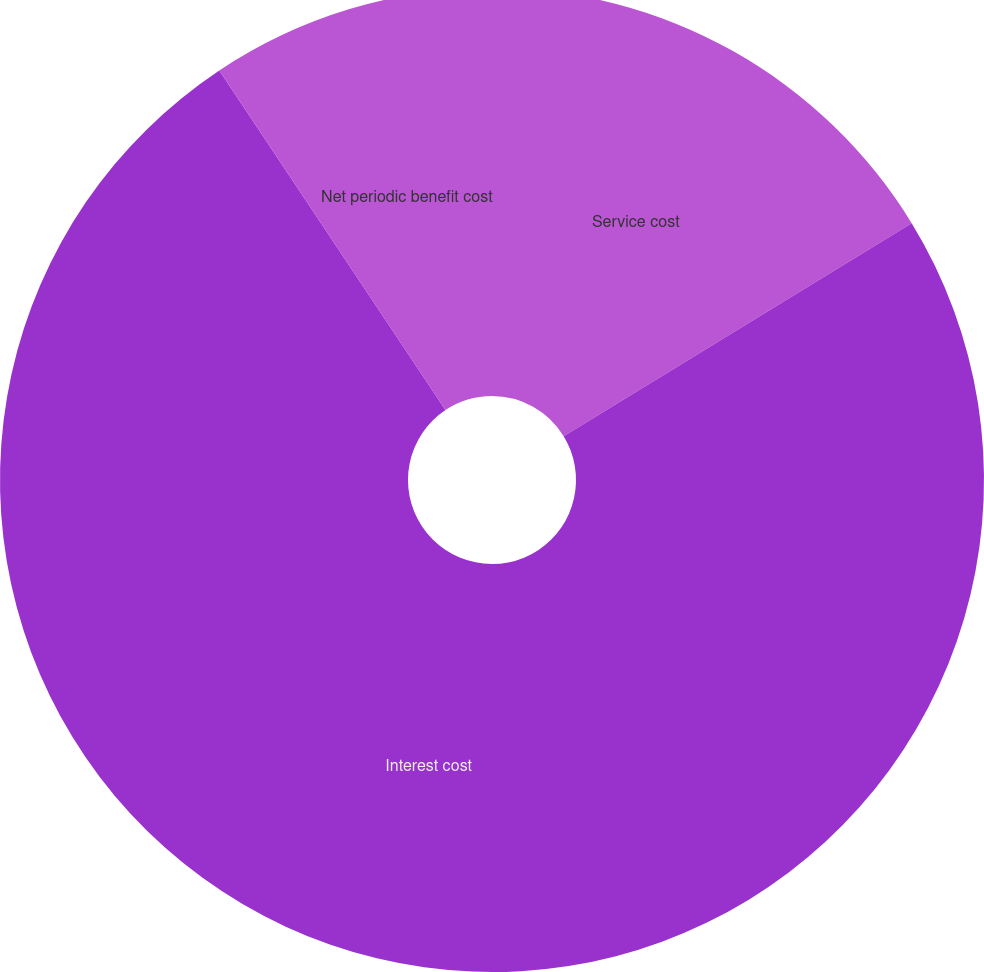Convert chart. <chart><loc_0><loc_0><loc_500><loc_500><pie_chart><fcel>Service cost<fcel>Interest cost<fcel>Net periodic benefit cost<nl><fcel>16.26%<fcel>74.39%<fcel>9.35%<nl></chart> 